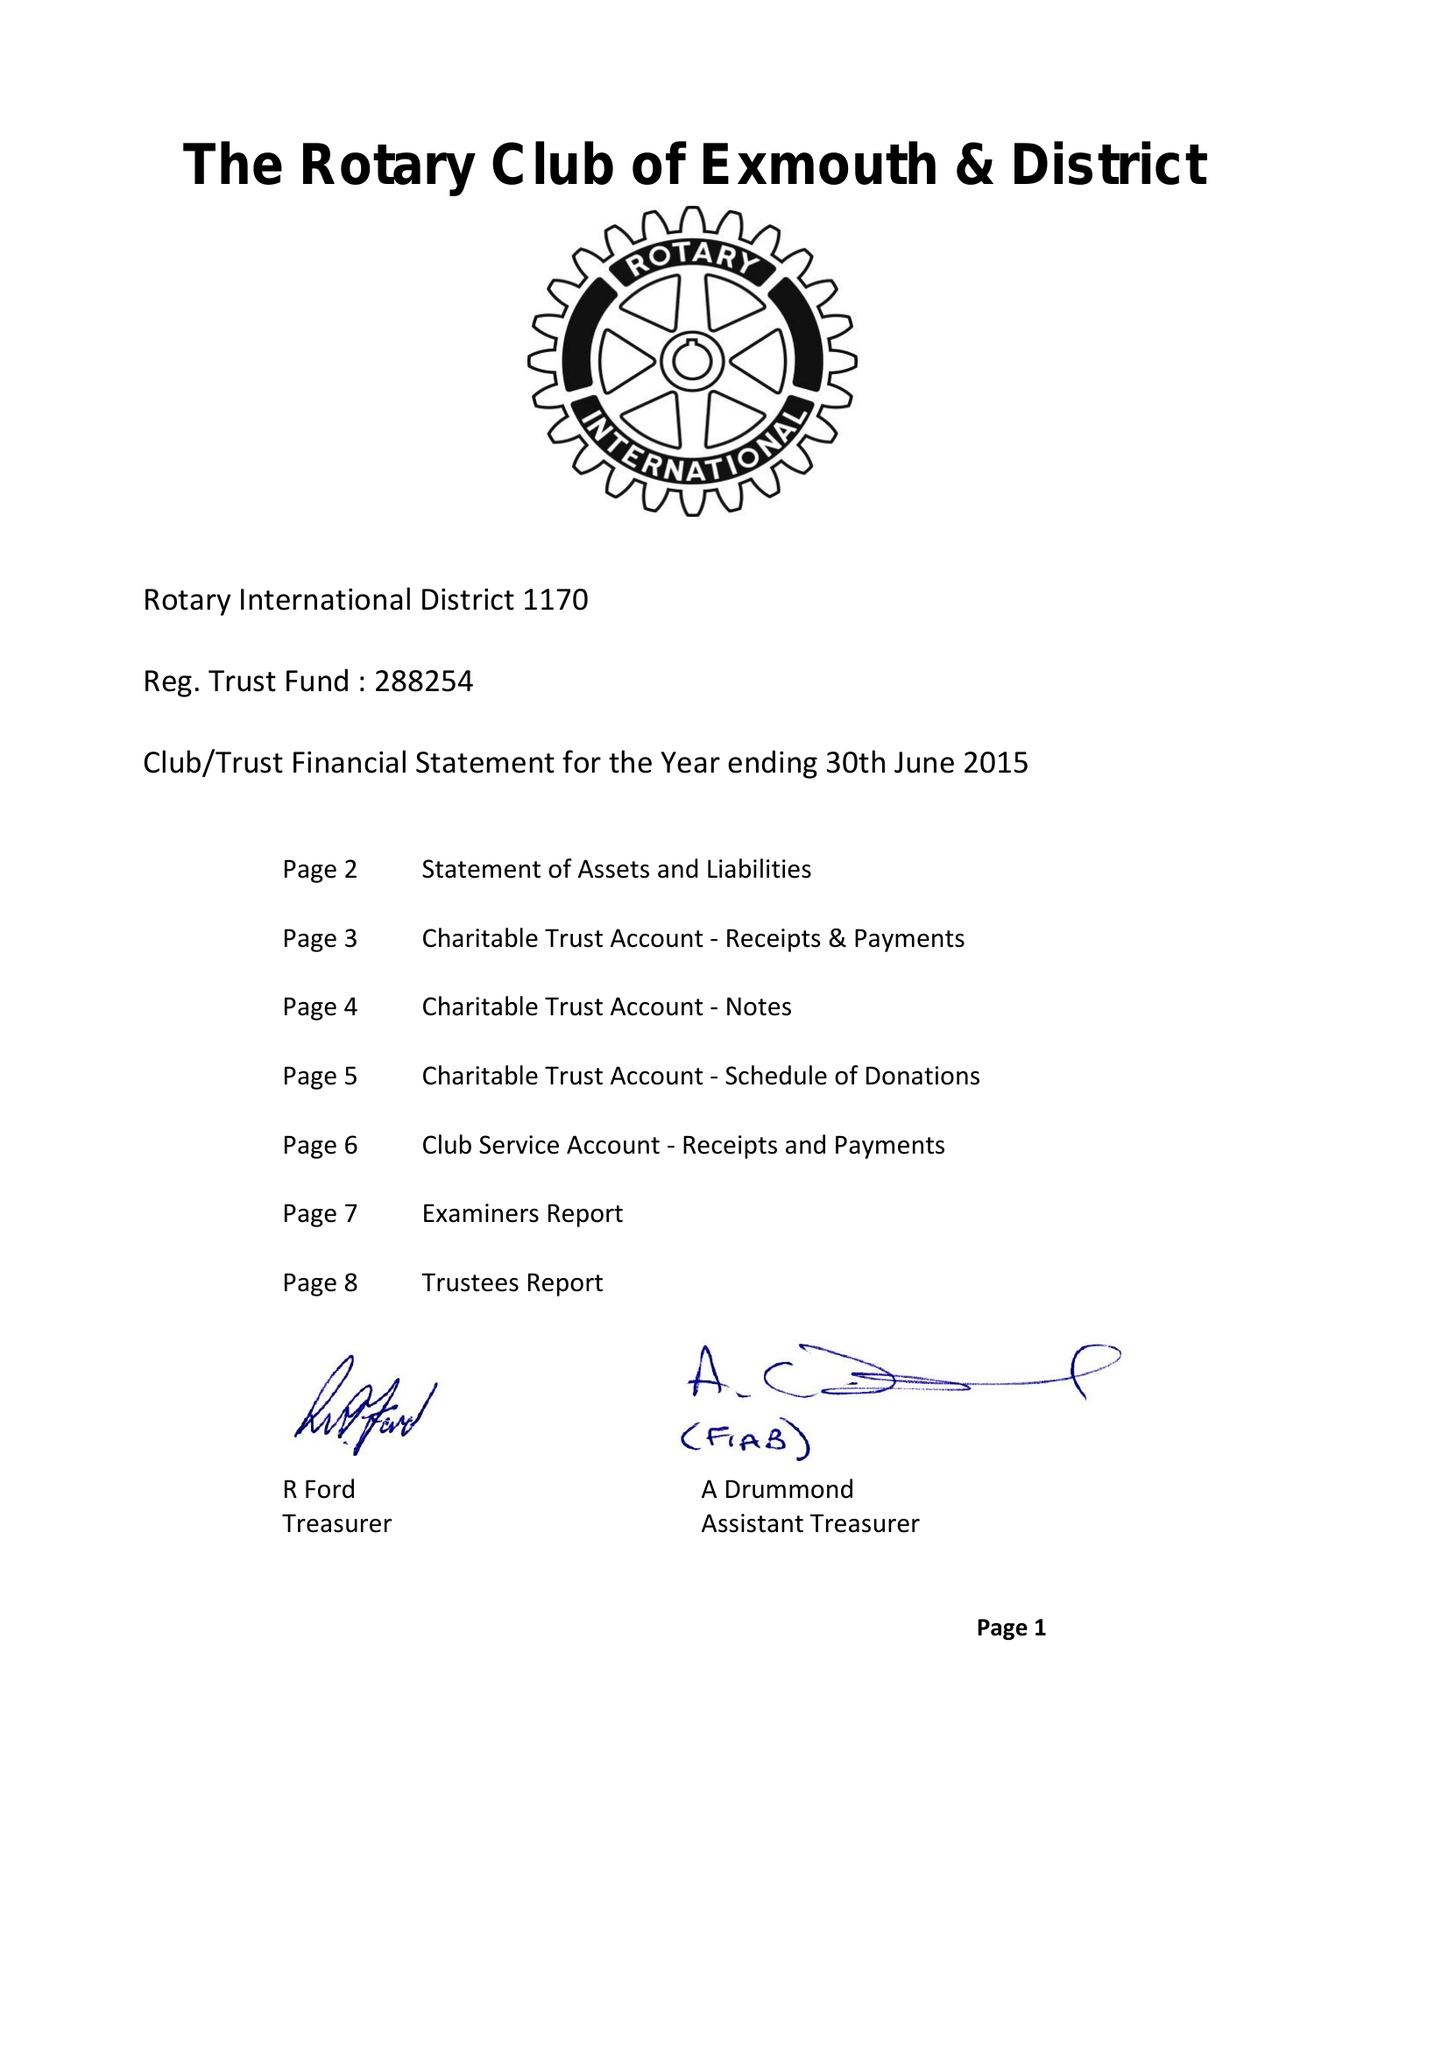What is the value for the charity_number?
Answer the question using a single word or phrase. 288254 